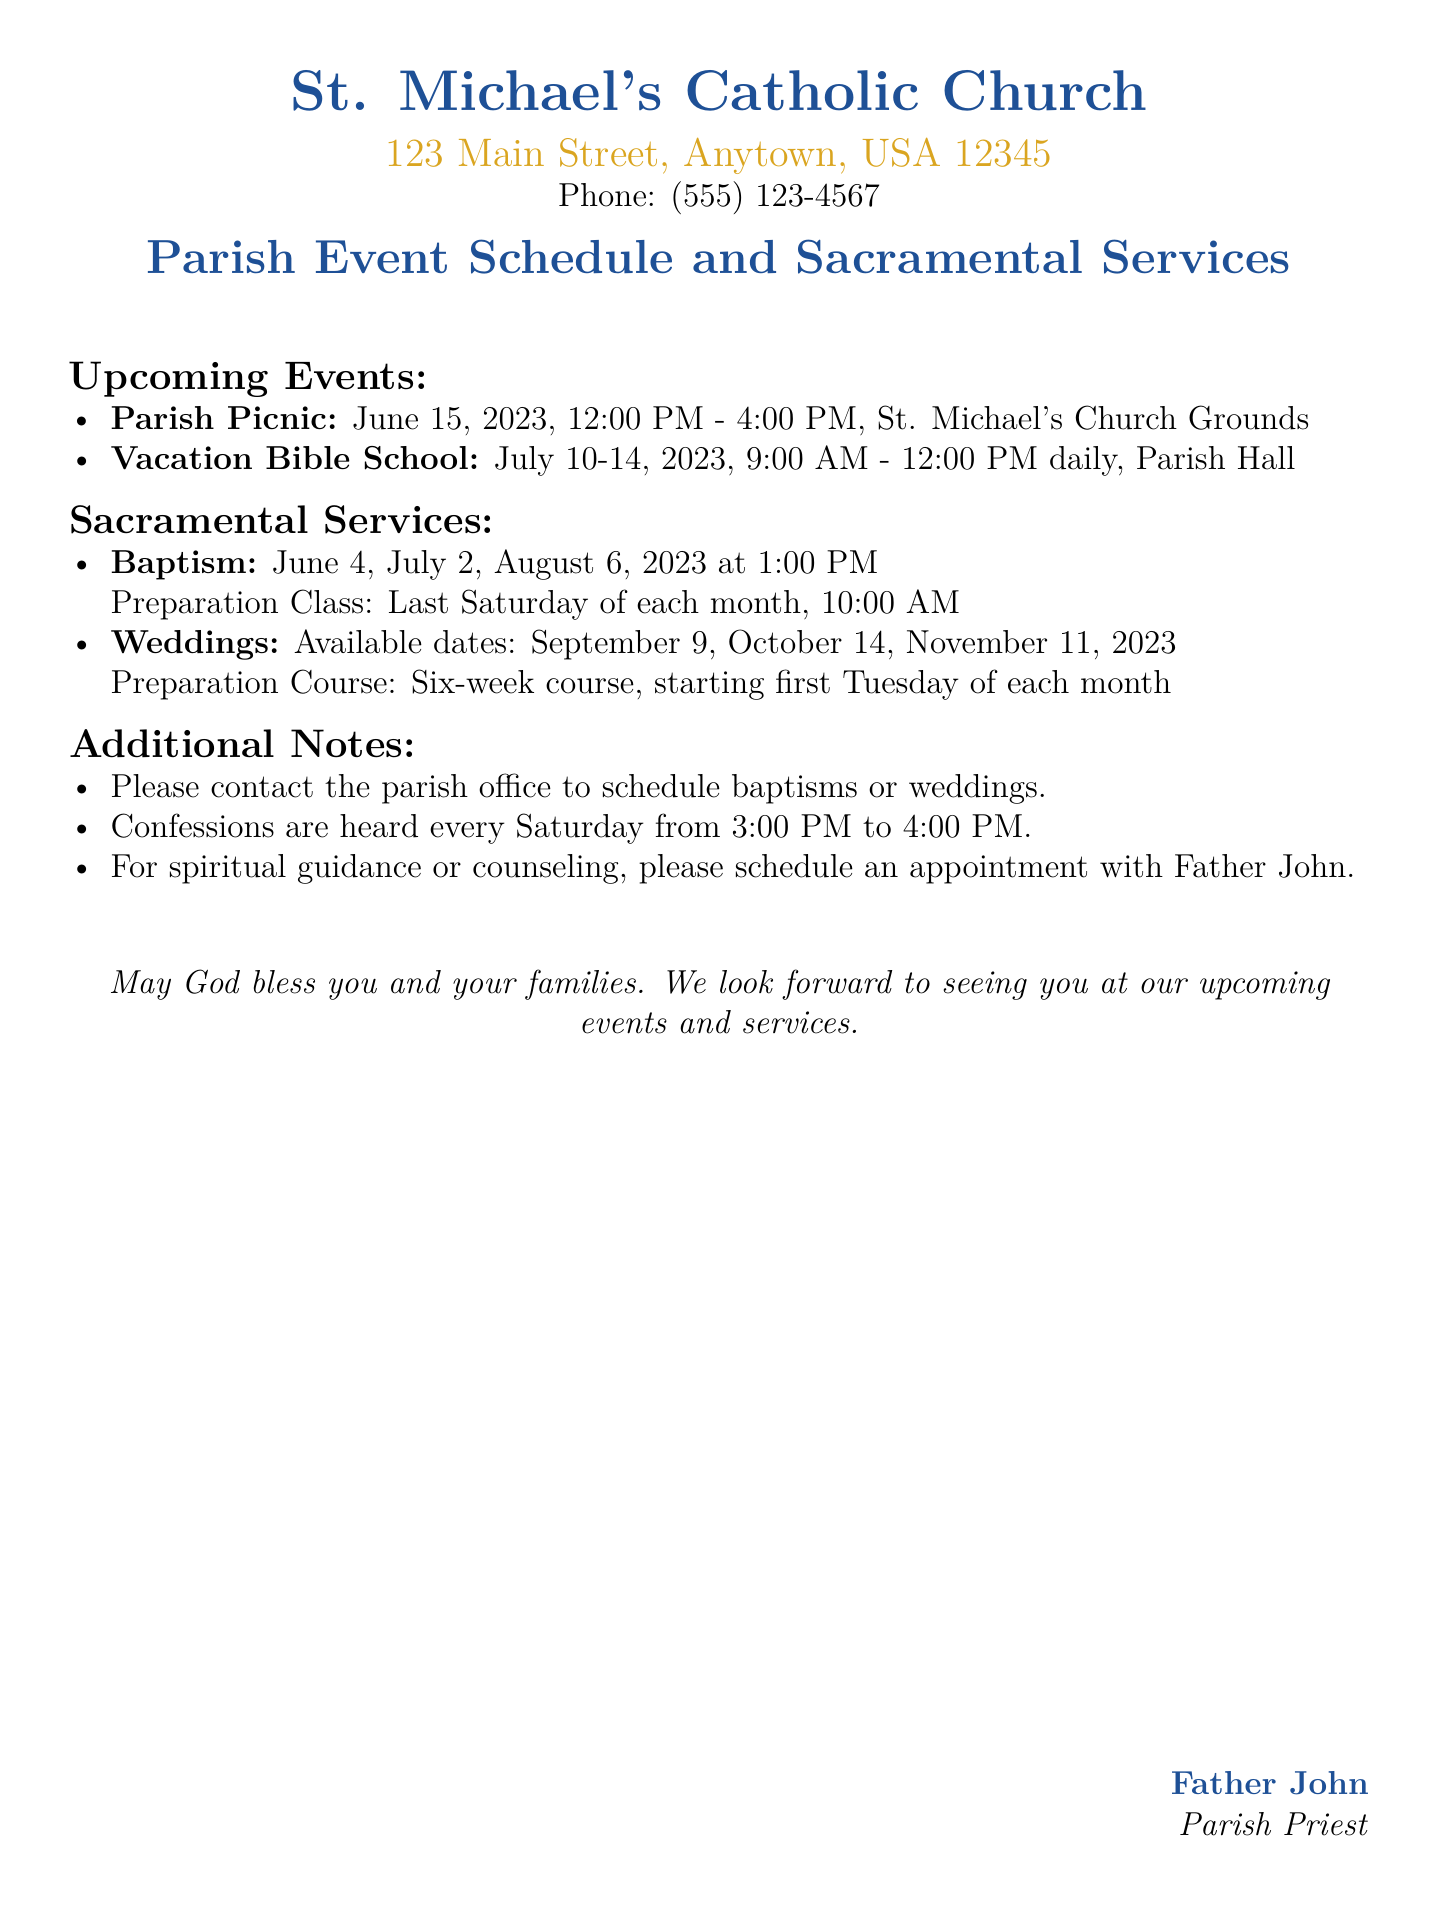What is the date of the Parish Picnic? The document states that the Parish Picnic is scheduled for June 15, 2023.
Answer: June 15, 2023 What time does the Vacation Bible School start? The Vacation Bible School is indicated to start at 9:00 AM.
Answer: 9:00 AM When are the Baptisms scheduled? The document mentions Baptisms are scheduled for June 4, July 2, and August 6, 2023.
Answer: June 4, July 2, August 6, 2023 How often are Confessions held? The document specifies that Confessions are held every Saturday.
Answer: Every Saturday What is the length of the Wedding Preparation Course? The document states that the Wedding Preparation Course is a six-week course.
Answer: Six-week course What is the contact for scheduling weddings? The document advises to contact the parish office to schedule weddings.
Answer: Parish office On what day does the Baptism Preparation Class occur? The document specifies that the Baptism Preparation Class takes place on the last Saturday of each month.
Answer: Last Saturday of each month What is the first Tuesday of which month in 2023 will the Wedding Preparation Course start? The text indicates that the Wedding Preparation Course starts on the first Tuesday of each month.
Answer: September 